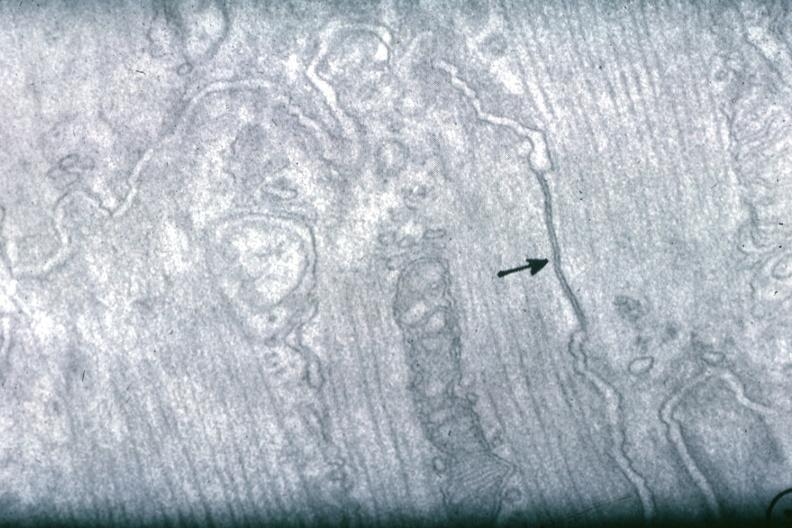what does this image show?
Answer the question using a single word or phrase. Junctional complex between two cells 